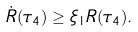Convert formula to latex. <formula><loc_0><loc_0><loc_500><loc_500>\dot { R } ( \tau _ { 4 } ) \geq \xi _ { 1 } R ( \tau _ { 4 } ) .</formula> 